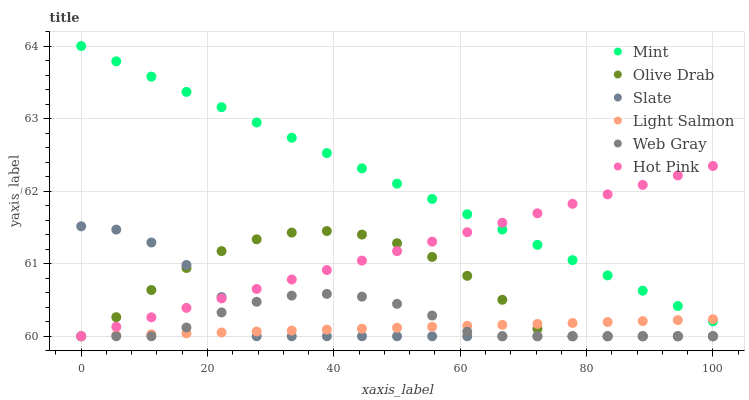Does Light Salmon have the minimum area under the curve?
Answer yes or no. Yes. Does Mint have the maximum area under the curve?
Answer yes or no. Yes. Does Web Gray have the minimum area under the curve?
Answer yes or no. No. Does Web Gray have the maximum area under the curve?
Answer yes or no. No. Is Hot Pink the smoothest?
Answer yes or no. Yes. Is Olive Drab the roughest?
Answer yes or no. Yes. Is Web Gray the smoothest?
Answer yes or no. No. Is Web Gray the roughest?
Answer yes or no. No. Does Light Salmon have the lowest value?
Answer yes or no. Yes. Does Mint have the lowest value?
Answer yes or no. No. Does Mint have the highest value?
Answer yes or no. Yes. Does Web Gray have the highest value?
Answer yes or no. No. Is Web Gray less than Mint?
Answer yes or no. Yes. Is Mint greater than Web Gray?
Answer yes or no. Yes. Does Light Salmon intersect Hot Pink?
Answer yes or no. Yes. Is Light Salmon less than Hot Pink?
Answer yes or no. No. Is Light Salmon greater than Hot Pink?
Answer yes or no. No. Does Web Gray intersect Mint?
Answer yes or no. No. 